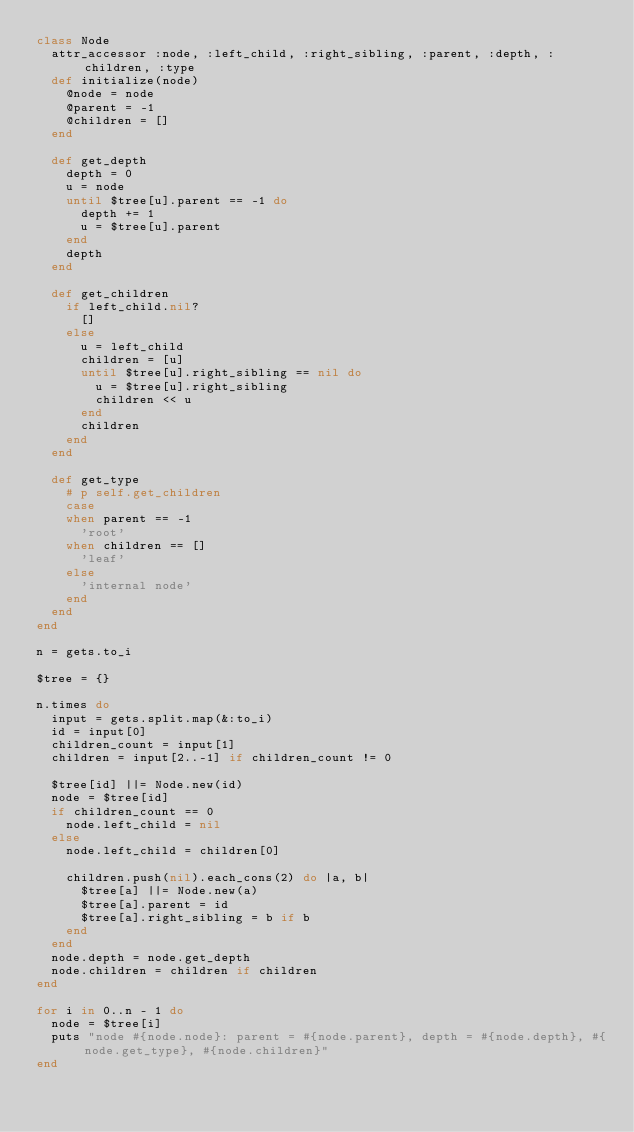<code> <loc_0><loc_0><loc_500><loc_500><_Ruby_>class Node
  attr_accessor :node, :left_child, :right_sibling, :parent, :depth, :children, :type
  def initialize(node)
    @node = node
    @parent = -1
    @children = []
  end

  def get_depth
    depth = 0
    u = node
    until $tree[u].parent == -1 do
      depth += 1
      u = $tree[u].parent
    end
    depth
  end

  def get_children
    if left_child.nil?
      []
    else
      u = left_child
      children = [u]
      until $tree[u].right_sibling == nil do
        u = $tree[u].right_sibling
        children << u
      end
      children
    end
  end

  def get_type
    # p self.get_children
    case
    when parent == -1
      'root'
    when children == []
      'leaf'
    else
      'internal node'
    end
  end
end

n = gets.to_i

$tree = {}

n.times do
  input = gets.split.map(&:to_i)
  id = input[0]
  children_count = input[1]
  children = input[2..-1] if children_count != 0

  $tree[id] ||= Node.new(id)
  node = $tree[id]
  if children_count == 0
    node.left_child = nil
  else
    node.left_child = children[0]

    children.push(nil).each_cons(2) do |a, b|
      $tree[a] ||= Node.new(a)
      $tree[a].parent = id
      $tree[a].right_sibling = b if b
    end
  end
  node.depth = node.get_depth
  node.children = children if children
end

for i in 0..n - 1 do
  node = $tree[i]
  puts "node #{node.node}: parent = #{node.parent}, depth = #{node.depth}, #{node.get_type}, #{node.children}"
end


</code> 